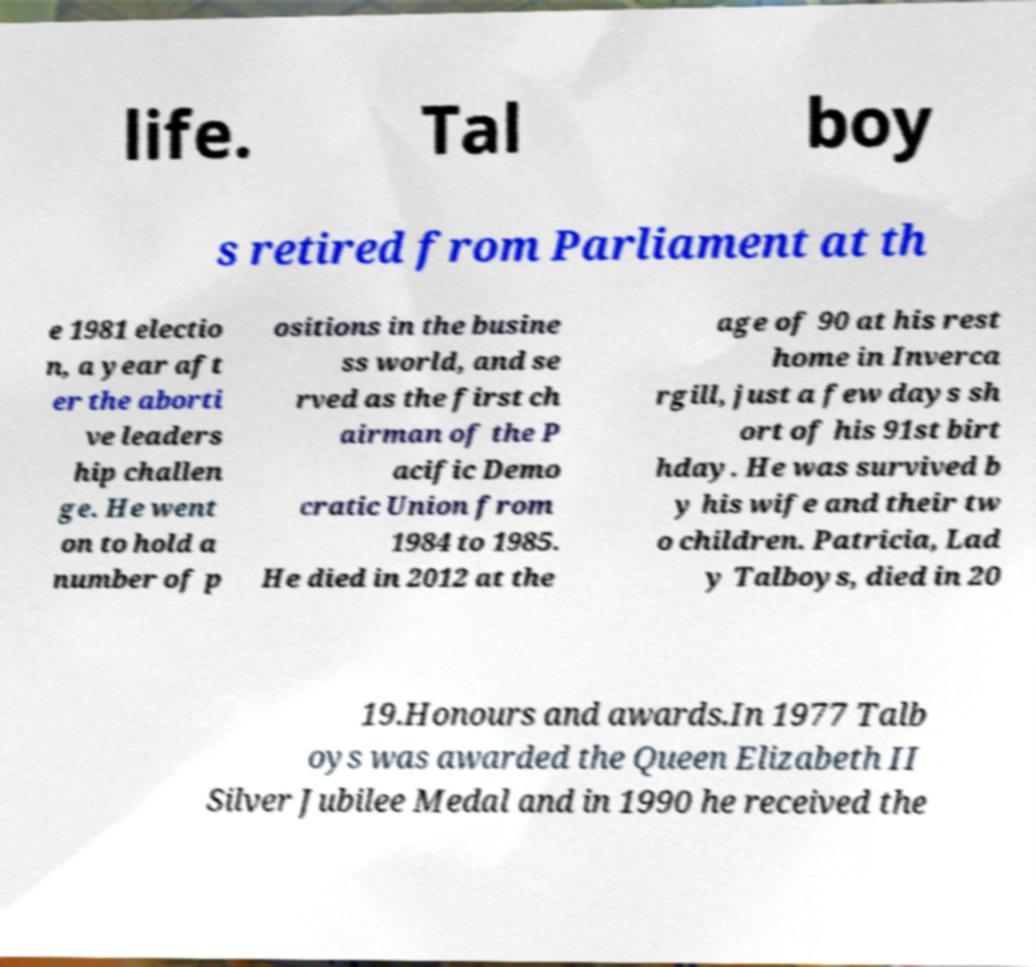Can you accurately transcribe the text from the provided image for me? life. Tal boy s retired from Parliament at th e 1981 electio n, a year aft er the aborti ve leaders hip challen ge. He went on to hold a number of p ositions in the busine ss world, and se rved as the first ch airman of the P acific Demo cratic Union from 1984 to 1985. He died in 2012 at the age of 90 at his rest home in Inverca rgill, just a few days sh ort of his 91st birt hday. He was survived b y his wife and their tw o children. Patricia, Lad y Talboys, died in 20 19.Honours and awards.In 1977 Talb oys was awarded the Queen Elizabeth II Silver Jubilee Medal and in 1990 he received the 